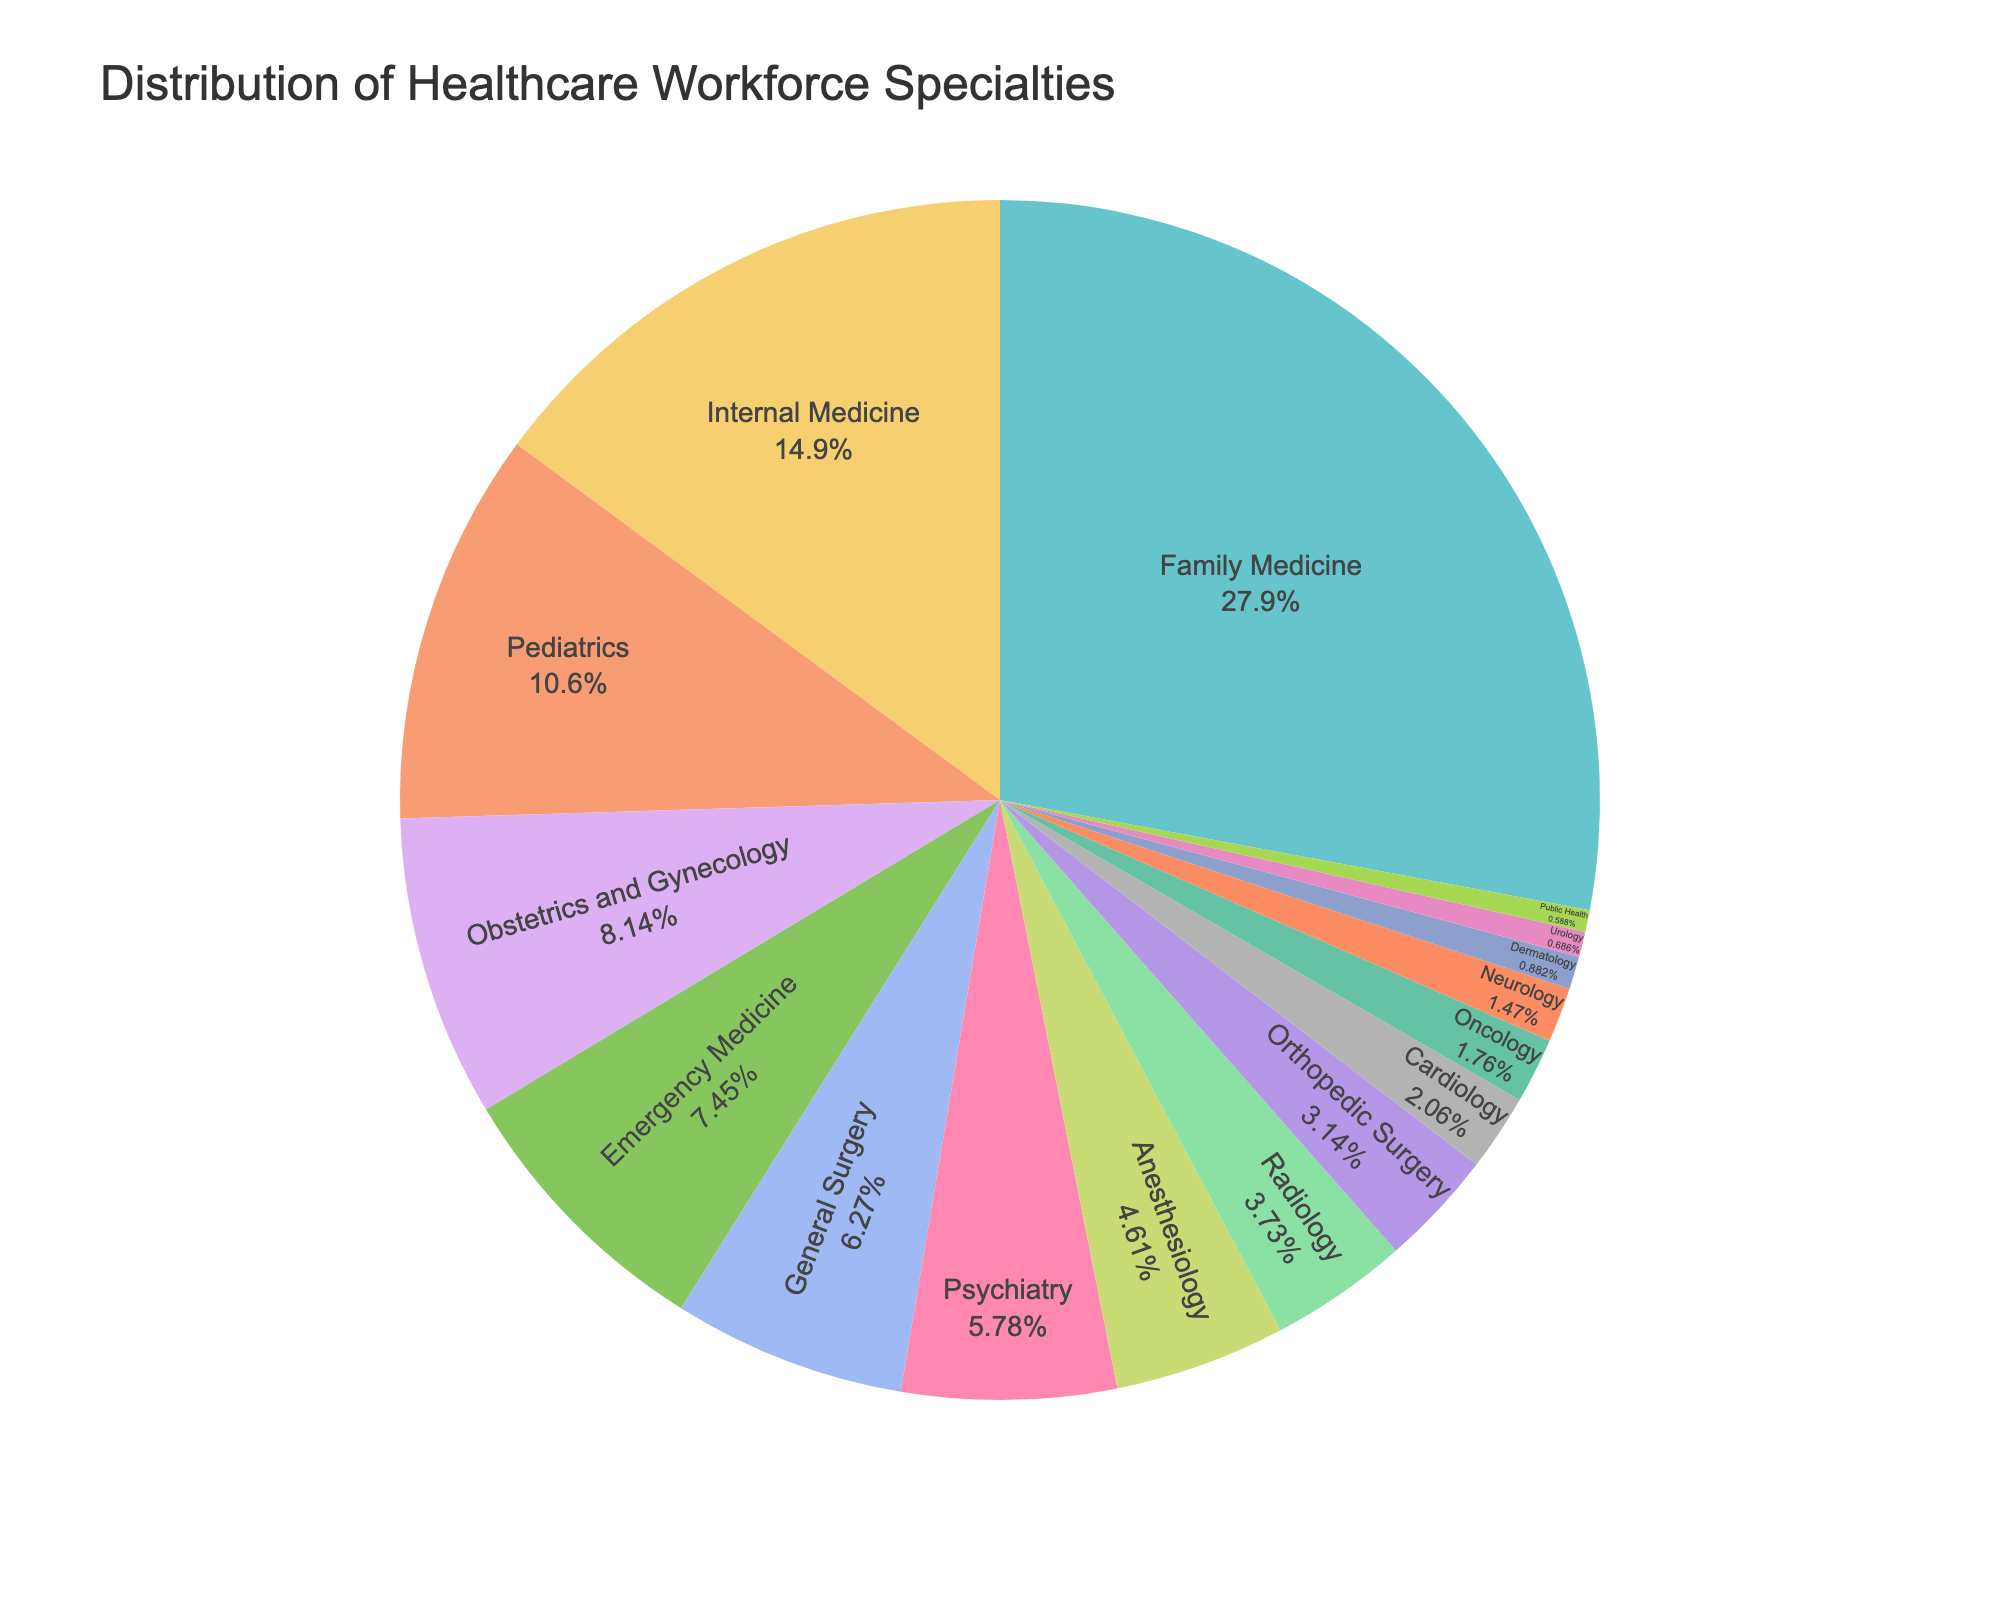What specialty has the highest percentage in the distribution? The figure shows the distribution of healthcare workforce specialties, and the largest segment corresponds to Family Medicine, constituting the highest percentage.
Answer: Family Medicine What is the combined percentage of the Internal Medicine, Pediatrics, and Emergency Medicine specialties? The figure shows the individual percentages for Internal Medicine (15.2%), Pediatrics (10.8%), and Emergency Medicine (7.6%). Adding them together: 15.2% + 10.8% + 7.6% = 33.6%.
Answer: 33.6% Is Psychiatry more common than General Surgery? By examining the figure, we notice that General Surgery (6.4%) has a slightly larger segment than Psychiatry (5.9%), indicating that General Surgery is more common.
Answer: No Which specialty has a lower percentage, Dermatology or Urology? The figure identifies the segment for Dermatology at 0.9% and the segment for Urology at 0.7%. Comparing these values, Urology has a lower percentage.
Answer: Urology How much more prevalent is Family Medicine compared to Cardiology? The figure indicates that Family Medicine is 28.5% and Cardiology is 2.1%. Calculating the difference: 28.5% - 2.1% = 26.4%.
Answer: 26.4% What is the total percentage of all surgical-related specialties (General Surgery, Orthopedic Surgery, and Urology)? The figure shows the individual percentages as General Surgery (6.4%), Orthopedic Surgery (3.2%), and Urology (0.7%). Summing them up: 6.4% + 3.2% + 0.7% = 10.3%.
Answer: 10.3% What is the combined percentage of Oncology and Neurology? The figure displays Oncology at 1.8% and Neurology at 1.5%. Adding them together: 1.8% + 1.5% = 3.3%.
Answer: 3.3% What are the two specialties with the smallest percentages, and what is their combined percentage? The figure marks Public Health at 0.6% and Urology at 0.7% as the smallest segments. Adding them together: 0.6% + 0.7% = 1.3%.
Answer: Public Health and Urology, 1.3% Is the segment for Pediatrics larger or smaller than that for Internal Medicine? The figure outlines Pediatrics with a 10.8% segment and Internal Medicine with a 15.2% segment. Pediatrics is smaller.
Answer: Smaller Which specialties have percentages close to or less than 5%, and what is their total combined percentage? The figure shows Psychiatry (5.9%), Anesthesiology (4.7%), Radiology (3.8%), Orthopedic Surgery (3.2%), Cardiology (2.1%), Oncology (1.8%), Neurology (1.5%), Dermatology (0.9%), Urology (0.7%), and Public Health (0.6%). Excluding those above 5%, the rest sum up to: 4.7% + 3.8% + 3.2% + 2.1% + 1.8% + 1.5% + 0.9% + 0.7% + 0.6% = 19.3%.
Answer: Psychiatry, Anesthesiology, Radiology, Orthopedic Surgery, Cardiology, Oncology, Neurology, Dermatology, Urology, Public Health. Combined percentage is 19.3% 